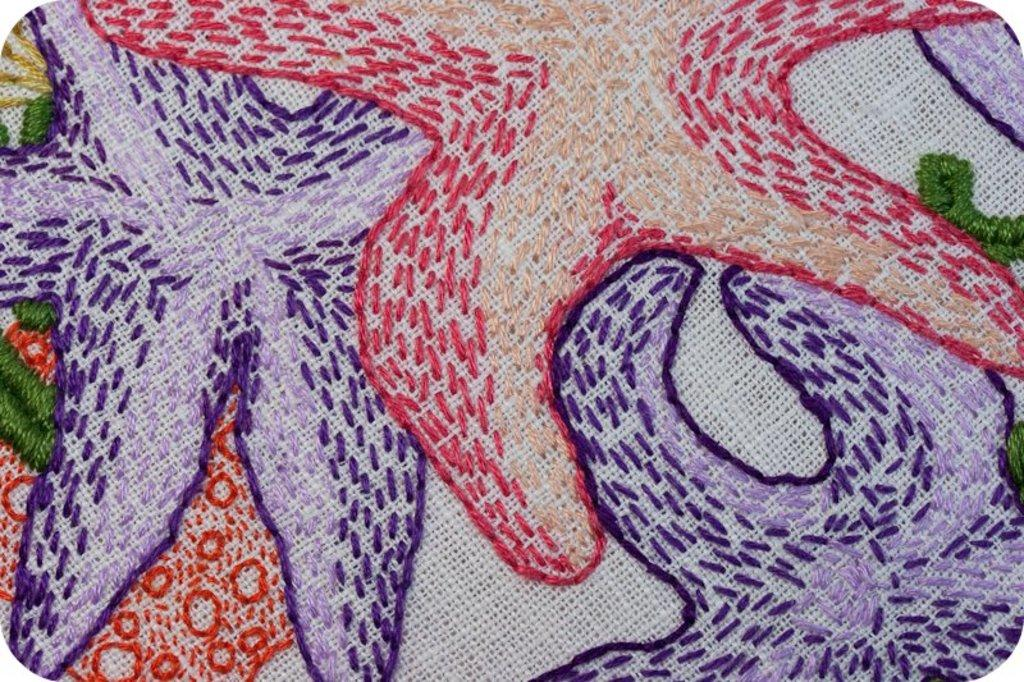What type of decoration can be seen on the cloth in the image? There is embroidery on a cloth in the image. What is the temper of the person teaching with a rod in the image? There is no person teaching with a rod in the image; it only features embroidery on a cloth. 